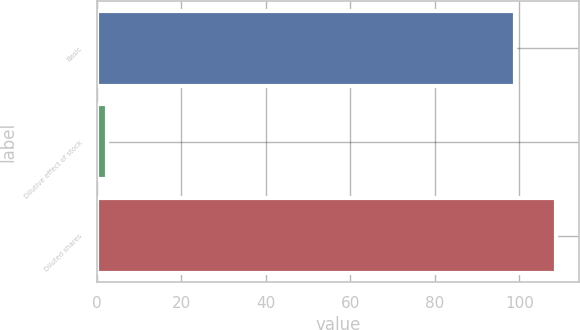Convert chart to OTSL. <chart><loc_0><loc_0><loc_500><loc_500><bar_chart><fcel>Basic<fcel>Dilutive effect of stock<fcel>Diluted shares<nl><fcel>98.9<fcel>2.4<fcel>108.79<nl></chart> 